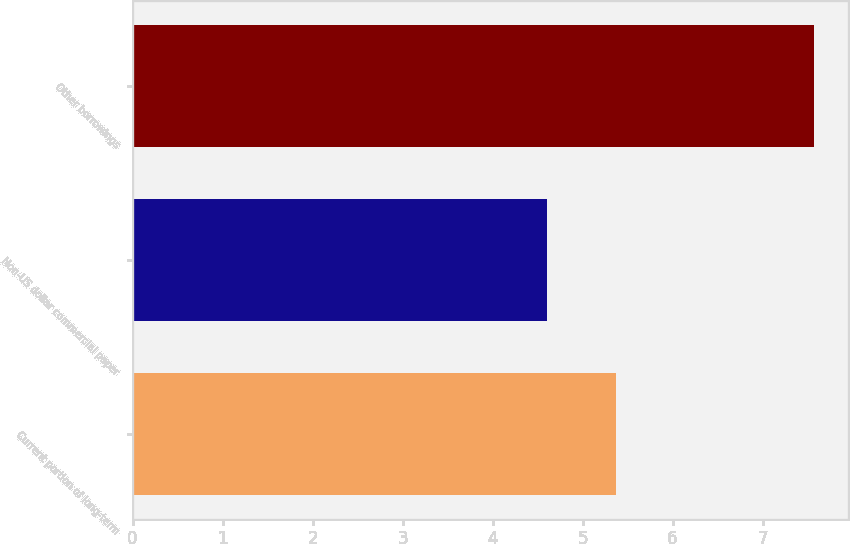Convert chart to OTSL. <chart><loc_0><loc_0><loc_500><loc_500><bar_chart><fcel>Current portion of long-term<fcel>Non-US dollar commercial paper<fcel>Other borrowings<nl><fcel>5.37<fcel>4.6<fcel>7.57<nl></chart> 